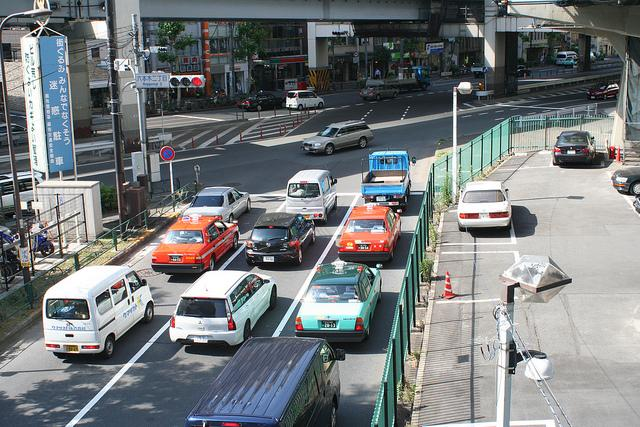What make is the white vehicle to the left of the green white cab? van 